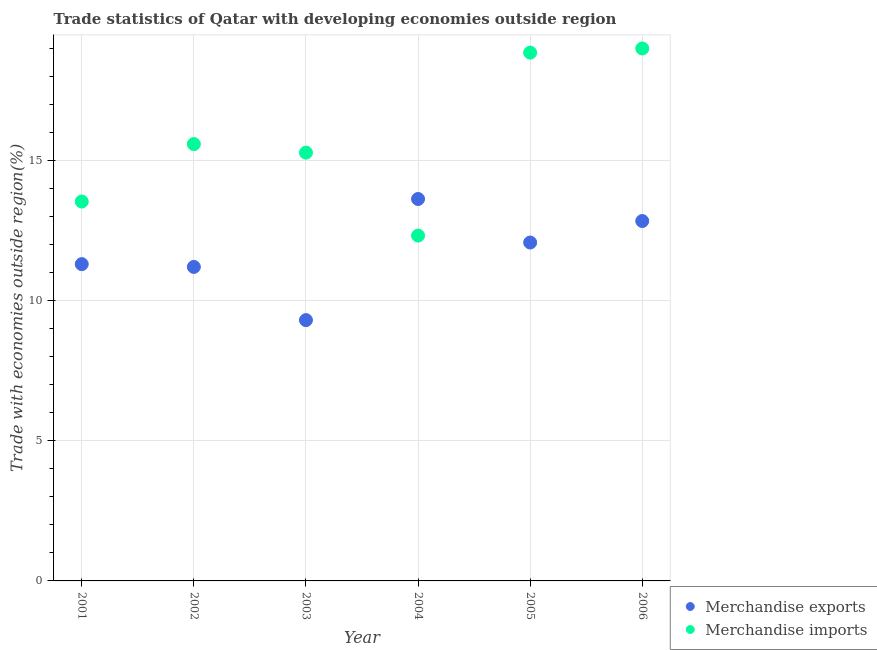Is the number of dotlines equal to the number of legend labels?
Your response must be concise. Yes. What is the merchandise exports in 2005?
Offer a terse response. 12.08. Across all years, what is the maximum merchandise exports?
Provide a succinct answer. 13.63. Across all years, what is the minimum merchandise exports?
Make the answer very short. 9.31. In which year was the merchandise imports minimum?
Your answer should be very brief. 2004. What is the total merchandise exports in the graph?
Your answer should be compact. 70.39. What is the difference between the merchandise imports in 2001 and that in 2004?
Make the answer very short. 1.22. What is the difference between the merchandise imports in 2003 and the merchandise exports in 2001?
Provide a short and direct response. 3.98. What is the average merchandise exports per year?
Keep it short and to the point. 11.73. In the year 2001, what is the difference between the merchandise imports and merchandise exports?
Ensure brevity in your answer.  2.24. What is the ratio of the merchandise exports in 2004 to that in 2005?
Your answer should be compact. 1.13. Is the merchandise imports in 2002 less than that in 2005?
Give a very brief answer. Yes. Is the difference between the merchandise imports in 2003 and 2006 greater than the difference between the merchandise exports in 2003 and 2006?
Your answer should be compact. No. What is the difference between the highest and the second highest merchandise imports?
Your response must be concise. 0.15. What is the difference between the highest and the lowest merchandise imports?
Provide a short and direct response. 6.68. Does the merchandise imports monotonically increase over the years?
Offer a terse response. No. Is the merchandise exports strictly less than the merchandise imports over the years?
Provide a succinct answer. No. Are the values on the major ticks of Y-axis written in scientific E-notation?
Your answer should be compact. No. Where does the legend appear in the graph?
Your answer should be compact. Bottom right. How many legend labels are there?
Your response must be concise. 2. How are the legend labels stacked?
Your answer should be very brief. Vertical. What is the title of the graph?
Give a very brief answer. Trade statistics of Qatar with developing economies outside region. Does "Secondary Education" appear as one of the legend labels in the graph?
Provide a succinct answer. No. What is the label or title of the X-axis?
Provide a succinct answer. Year. What is the label or title of the Y-axis?
Make the answer very short. Trade with economies outside region(%). What is the Trade with economies outside region(%) in Merchandise exports in 2001?
Give a very brief answer. 11.31. What is the Trade with economies outside region(%) in Merchandise imports in 2001?
Your answer should be compact. 13.54. What is the Trade with economies outside region(%) in Merchandise exports in 2002?
Ensure brevity in your answer.  11.21. What is the Trade with economies outside region(%) in Merchandise imports in 2002?
Keep it short and to the point. 15.59. What is the Trade with economies outside region(%) of Merchandise exports in 2003?
Offer a terse response. 9.31. What is the Trade with economies outside region(%) of Merchandise imports in 2003?
Keep it short and to the point. 15.29. What is the Trade with economies outside region(%) of Merchandise exports in 2004?
Give a very brief answer. 13.63. What is the Trade with economies outside region(%) of Merchandise imports in 2004?
Give a very brief answer. 12.33. What is the Trade with economies outside region(%) of Merchandise exports in 2005?
Keep it short and to the point. 12.08. What is the Trade with economies outside region(%) of Merchandise imports in 2005?
Provide a short and direct response. 18.86. What is the Trade with economies outside region(%) in Merchandise exports in 2006?
Provide a succinct answer. 12.85. What is the Trade with economies outside region(%) in Merchandise imports in 2006?
Provide a short and direct response. 19.01. Across all years, what is the maximum Trade with economies outside region(%) of Merchandise exports?
Make the answer very short. 13.63. Across all years, what is the maximum Trade with economies outside region(%) of Merchandise imports?
Provide a succinct answer. 19.01. Across all years, what is the minimum Trade with economies outside region(%) of Merchandise exports?
Ensure brevity in your answer.  9.31. Across all years, what is the minimum Trade with economies outside region(%) in Merchandise imports?
Make the answer very short. 12.33. What is the total Trade with economies outside region(%) of Merchandise exports in the graph?
Your response must be concise. 70.39. What is the total Trade with economies outside region(%) in Merchandise imports in the graph?
Offer a terse response. 94.62. What is the difference between the Trade with economies outside region(%) in Merchandise exports in 2001 and that in 2002?
Provide a succinct answer. 0.1. What is the difference between the Trade with economies outside region(%) in Merchandise imports in 2001 and that in 2002?
Offer a terse response. -2.05. What is the difference between the Trade with economies outside region(%) in Merchandise exports in 2001 and that in 2003?
Keep it short and to the point. 2. What is the difference between the Trade with economies outside region(%) in Merchandise imports in 2001 and that in 2003?
Offer a terse response. -1.75. What is the difference between the Trade with economies outside region(%) of Merchandise exports in 2001 and that in 2004?
Your response must be concise. -2.33. What is the difference between the Trade with economies outside region(%) in Merchandise imports in 2001 and that in 2004?
Make the answer very short. 1.22. What is the difference between the Trade with economies outside region(%) of Merchandise exports in 2001 and that in 2005?
Provide a succinct answer. -0.77. What is the difference between the Trade with economies outside region(%) of Merchandise imports in 2001 and that in 2005?
Offer a very short reply. -5.32. What is the difference between the Trade with economies outside region(%) in Merchandise exports in 2001 and that in 2006?
Keep it short and to the point. -1.54. What is the difference between the Trade with economies outside region(%) of Merchandise imports in 2001 and that in 2006?
Offer a very short reply. -5.46. What is the difference between the Trade with economies outside region(%) of Merchandise exports in 2002 and that in 2003?
Ensure brevity in your answer.  1.9. What is the difference between the Trade with economies outside region(%) in Merchandise imports in 2002 and that in 2003?
Make the answer very short. 0.3. What is the difference between the Trade with economies outside region(%) of Merchandise exports in 2002 and that in 2004?
Give a very brief answer. -2.42. What is the difference between the Trade with economies outside region(%) in Merchandise imports in 2002 and that in 2004?
Your answer should be very brief. 3.27. What is the difference between the Trade with economies outside region(%) of Merchandise exports in 2002 and that in 2005?
Your response must be concise. -0.87. What is the difference between the Trade with economies outside region(%) of Merchandise imports in 2002 and that in 2005?
Your response must be concise. -3.27. What is the difference between the Trade with economies outside region(%) of Merchandise exports in 2002 and that in 2006?
Your answer should be compact. -1.64. What is the difference between the Trade with economies outside region(%) in Merchandise imports in 2002 and that in 2006?
Provide a succinct answer. -3.41. What is the difference between the Trade with economies outside region(%) of Merchandise exports in 2003 and that in 2004?
Your answer should be very brief. -4.32. What is the difference between the Trade with economies outside region(%) of Merchandise imports in 2003 and that in 2004?
Make the answer very short. 2.96. What is the difference between the Trade with economies outside region(%) of Merchandise exports in 2003 and that in 2005?
Give a very brief answer. -2.77. What is the difference between the Trade with economies outside region(%) in Merchandise imports in 2003 and that in 2005?
Ensure brevity in your answer.  -3.57. What is the difference between the Trade with economies outside region(%) of Merchandise exports in 2003 and that in 2006?
Make the answer very short. -3.54. What is the difference between the Trade with economies outside region(%) in Merchandise imports in 2003 and that in 2006?
Give a very brief answer. -3.72. What is the difference between the Trade with economies outside region(%) in Merchandise exports in 2004 and that in 2005?
Keep it short and to the point. 1.55. What is the difference between the Trade with economies outside region(%) of Merchandise imports in 2004 and that in 2005?
Offer a terse response. -6.53. What is the difference between the Trade with economies outside region(%) in Merchandise exports in 2004 and that in 2006?
Provide a succinct answer. 0.79. What is the difference between the Trade with economies outside region(%) in Merchandise imports in 2004 and that in 2006?
Offer a very short reply. -6.68. What is the difference between the Trade with economies outside region(%) in Merchandise exports in 2005 and that in 2006?
Make the answer very short. -0.77. What is the difference between the Trade with economies outside region(%) in Merchandise imports in 2005 and that in 2006?
Offer a terse response. -0.15. What is the difference between the Trade with economies outside region(%) in Merchandise exports in 2001 and the Trade with economies outside region(%) in Merchandise imports in 2002?
Provide a short and direct response. -4.29. What is the difference between the Trade with economies outside region(%) in Merchandise exports in 2001 and the Trade with economies outside region(%) in Merchandise imports in 2003?
Provide a succinct answer. -3.98. What is the difference between the Trade with economies outside region(%) of Merchandise exports in 2001 and the Trade with economies outside region(%) of Merchandise imports in 2004?
Make the answer very short. -1.02. What is the difference between the Trade with economies outside region(%) in Merchandise exports in 2001 and the Trade with economies outside region(%) in Merchandise imports in 2005?
Provide a succinct answer. -7.55. What is the difference between the Trade with economies outside region(%) in Merchandise exports in 2001 and the Trade with economies outside region(%) in Merchandise imports in 2006?
Your answer should be compact. -7.7. What is the difference between the Trade with economies outside region(%) in Merchandise exports in 2002 and the Trade with economies outside region(%) in Merchandise imports in 2003?
Your answer should be compact. -4.08. What is the difference between the Trade with economies outside region(%) of Merchandise exports in 2002 and the Trade with economies outside region(%) of Merchandise imports in 2004?
Make the answer very short. -1.12. What is the difference between the Trade with economies outside region(%) of Merchandise exports in 2002 and the Trade with economies outside region(%) of Merchandise imports in 2005?
Keep it short and to the point. -7.65. What is the difference between the Trade with economies outside region(%) in Merchandise exports in 2002 and the Trade with economies outside region(%) in Merchandise imports in 2006?
Offer a terse response. -7.8. What is the difference between the Trade with economies outside region(%) of Merchandise exports in 2003 and the Trade with economies outside region(%) of Merchandise imports in 2004?
Offer a very short reply. -3.02. What is the difference between the Trade with economies outside region(%) in Merchandise exports in 2003 and the Trade with economies outside region(%) in Merchandise imports in 2005?
Give a very brief answer. -9.55. What is the difference between the Trade with economies outside region(%) in Merchandise exports in 2003 and the Trade with economies outside region(%) in Merchandise imports in 2006?
Your response must be concise. -9.7. What is the difference between the Trade with economies outside region(%) in Merchandise exports in 2004 and the Trade with economies outside region(%) in Merchandise imports in 2005?
Make the answer very short. -5.23. What is the difference between the Trade with economies outside region(%) of Merchandise exports in 2004 and the Trade with economies outside region(%) of Merchandise imports in 2006?
Your answer should be very brief. -5.37. What is the difference between the Trade with economies outside region(%) in Merchandise exports in 2005 and the Trade with economies outside region(%) in Merchandise imports in 2006?
Your response must be concise. -6.93. What is the average Trade with economies outside region(%) in Merchandise exports per year?
Ensure brevity in your answer.  11.73. What is the average Trade with economies outside region(%) of Merchandise imports per year?
Offer a very short reply. 15.77. In the year 2001, what is the difference between the Trade with economies outside region(%) of Merchandise exports and Trade with economies outside region(%) of Merchandise imports?
Your response must be concise. -2.24. In the year 2002, what is the difference between the Trade with economies outside region(%) of Merchandise exports and Trade with economies outside region(%) of Merchandise imports?
Provide a succinct answer. -4.38. In the year 2003, what is the difference between the Trade with economies outside region(%) in Merchandise exports and Trade with economies outside region(%) in Merchandise imports?
Offer a terse response. -5.98. In the year 2004, what is the difference between the Trade with economies outside region(%) in Merchandise exports and Trade with economies outside region(%) in Merchandise imports?
Make the answer very short. 1.31. In the year 2005, what is the difference between the Trade with economies outside region(%) in Merchandise exports and Trade with economies outside region(%) in Merchandise imports?
Give a very brief answer. -6.78. In the year 2006, what is the difference between the Trade with economies outside region(%) in Merchandise exports and Trade with economies outside region(%) in Merchandise imports?
Your answer should be compact. -6.16. What is the ratio of the Trade with economies outside region(%) of Merchandise exports in 2001 to that in 2002?
Your answer should be compact. 1.01. What is the ratio of the Trade with economies outside region(%) of Merchandise imports in 2001 to that in 2002?
Provide a short and direct response. 0.87. What is the ratio of the Trade with economies outside region(%) of Merchandise exports in 2001 to that in 2003?
Give a very brief answer. 1.21. What is the ratio of the Trade with economies outside region(%) of Merchandise imports in 2001 to that in 2003?
Offer a terse response. 0.89. What is the ratio of the Trade with economies outside region(%) in Merchandise exports in 2001 to that in 2004?
Your answer should be very brief. 0.83. What is the ratio of the Trade with economies outside region(%) in Merchandise imports in 2001 to that in 2004?
Keep it short and to the point. 1.1. What is the ratio of the Trade with economies outside region(%) in Merchandise exports in 2001 to that in 2005?
Ensure brevity in your answer.  0.94. What is the ratio of the Trade with economies outside region(%) of Merchandise imports in 2001 to that in 2005?
Offer a very short reply. 0.72. What is the ratio of the Trade with economies outside region(%) in Merchandise exports in 2001 to that in 2006?
Your response must be concise. 0.88. What is the ratio of the Trade with economies outside region(%) in Merchandise imports in 2001 to that in 2006?
Keep it short and to the point. 0.71. What is the ratio of the Trade with economies outside region(%) of Merchandise exports in 2002 to that in 2003?
Your answer should be compact. 1.2. What is the ratio of the Trade with economies outside region(%) of Merchandise imports in 2002 to that in 2003?
Offer a terse response. 1.02. What is the ratio of the Trade with economies outside region(%) of Merchandise exports in 2002 to that in 2004?
Give a very brief answer. 0.82. What is the ratio of the Trade with economies outside region(%) in Merchandise imports in 2002 to that in 2004?
Offer a very short reply. 1.26. What is the ratio of the Trade with economies outside region(%) of Merchandise exports in 2002 to that in 2005?
Your response must be concise. 0.93. What is the ratio of the Trade with economies outside region(%) of Merchandise imports in 2002 to that in 2005?
Provide a succinct answer. 0.83. What is the ratio of the Trade with economies outside region(%) of Merchandise exports in 2002 to that in 2006?
Offer a very short reply. 0.87. What is the ratio of the Trade with economies outside region(%) in Merchandise imports in 2002 to that in 2006?
Provide a succinct answer. 0.82. What is the ratio of the Trade with economies outside region(%) of Merchandise exports in 2003 to that in 2004?
Ensure brevity in your answer.  0.68. What is the ratio of the Trade with economies outside region(%) of Merchandise imports in 2003 to that in 2004?
Your answer should be compact. 1.24. What is the ratio of the Trade with economies outside region(%) in Merchandise exports in 2003 to that in 2005?
Your answer should be very brief. 0.77. What is the ratio of the Trade with economies outside region(%) in Merchandise imports in 2003 to that in 2005?
Offer a terse response. 0.81. What is the ratio of the Trade with economies outside region(%) in Merchandise exports in 2003 to that in 2006?
Offer a terse response. 0.72. What is the ratio of the Trade with economies outside region(%) of Merchandise imports in 2003 to that in 2006?
Offer a terse response. 0.8. What is the ratio of the Trade with economies outside region(%) of Merchandise exports in 2004 to that in 2005?
Keep it short and to the point. 1.13. What is the ratio of the Trade with economies outside region(%) of Merchandise imports in 2004 to that in 2005?
Provide a succinct answer. 0.65. What is the ratio of the Trade with economies outside region(%) of Merchandise exports in 2004 to that in 2006?
Ensure brevity in your answer.  1.06. What is the ratio of the Trade with economies outside region(%) of Merchandise imports in 2004 to that in 2006?
Keep it short and to the point. 0.65. What is the ratio of the Trade with economies outside region(%) of Merchandise exports in 2005 to that in 2006?
Provide a short and direct response. 0.94. What is the ratio of the Trade with economies outside region(%) of Merchandise imports in 2005 to that in 2006?
Keep it short and to the point. 0.99. What is the difference between the highest and the second highest Trade with economies outside region(%) in Merchandise exports?
Keep it short and to the point. 0.79. What is the difference between the highest and the second highest Trade with economies outside region(%) of Merchandise imports?
Provide a succinct answer. 0.15. What is the difference between the highest and the lowest Trade with economies outside region(%) in Merchandise exports?
Your answer should be compact. 4.32. What is the difference between the highest and the lowest Trade with economies outside region(%) in Merchandise imports?
Offer a terse response. 6.68. 